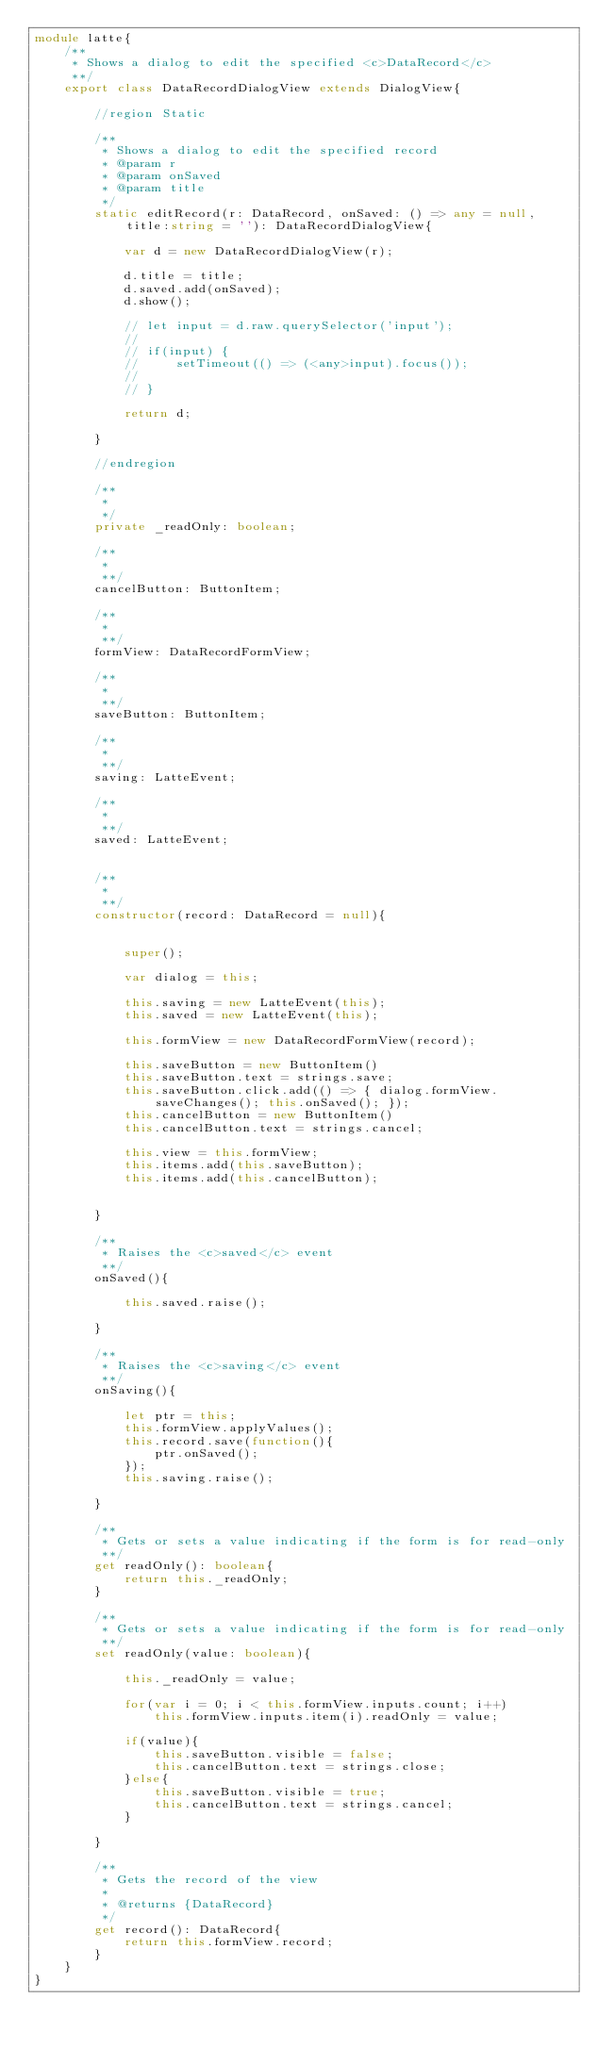<code> <loc_0><loc_0><loc_500><loc_500><_TypeScript_>module latte{
    /**
     * Shows a dialog to edit the specified <c>DataRecord</c>
     **/
    export class DataRecordDialogView extends DialogView{

        //region Static

        /**
         * Shows a dialog to edit the specified record
         * @param r
         * @param onSaved
         * @param title
         */
        static editRecord(r: DataRecord, onSaved: () => any = null, title:string = ''): DataRecordDialogView{

            var d = new DataRecordDialogView(r);

            d.title = title;
            d.saved.add(onSaved);
            d.show();

            // let input = d.raw.querySelector('input');
            //
            // if(input) {
            //     setTimeout(() => (<any>input).focus());
            //
            // }

            return d;

        }

        //endregion

        /**
         *
         */
        private _readOnly: boolean;

        /**
         *
         **/
        cancelButton: ButtonItem;

        /**
         *
         **/
        formView: DataRecordFormView;

        /**
         *
         **/
        saveButton: ButtonItem;

        /**
         *
         **/
        saving: LatteEvent;

        /**
         *
         **/
        saved: LatteEvent;


        /**
         *
         **/
        constructor(record: DataRecord = null){


            super();

            var dialog = this;

            this.saving = new LatteEvent(this);
            this.saved = new LatteEvent(this);

            this.formView = new DataRecordFormView(record);

            this.saveButton = new ButtonItem()
            this.saveButton.text = strings.save;
            this.saveButton.click.add(() => { dialog.formView.saveChanges(); this.onSaved(); });
            this.cancelButton = new ButtonItem()
            this.cancelButton.text = strings.cancel;

            this.view = this.formView;
            this.items.add(this.saveButton);
            this.items.add(this.cancelButton);


        }

        /**
         * Raises the <c>saved</c> event
         **/
        onSaved(){

            this.saved.raise();

        }

        /**
         * Raises the <c>saving</c> event
         **/
        onSaving(){

            let ptr = this;
            this.formView.applyValues();
            this.record.save(function(){
                ptr.onSaved();
            });
            this.saving.raise();

        }

        /**
         * Gets or sets a value indicating if the form is for read-only
         **/
        get readOnly(): boolean{
            return this._readOnly;
        }

        /**
         * Gets or sets a value indicating if the form is for read-only
         **/
        set readOnly(value: boolean){

            this._readOnly = value;

            for(var i = 0; i < this.formView.inputs.count; i++)
                this.formView.inputs.item(i).readOnly = value;

            if(value){
                this.saveButton.visible = false;
                this.cancelButton.text = strings.close;
            }else{
                this.saveButton.visible = true;
                this.cancelButton.text = strings.cancel;
            }

        }

        /**
         * Gets the record of the view
         *
         * @returns {DataRecord}
         */
        get record(): DataRecord{
            return this.formView.record;
        }
    }
}</code> 